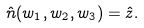Convert formula to latex. <formula><loc_0><loc_0><loc_500><loc_500>\hat { n } ( w _ { 1 } , w _ { 2 } , w _ { 3 } ) = \hat { z } .</formula> 